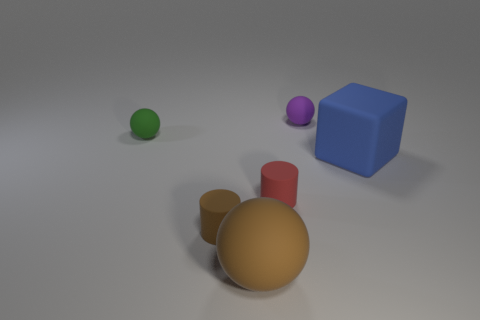How many big objects are either blue things or brown balls?
Offer a terse response. 2. The large thing to the right of the big brown matte object has what shape?
Keep it short and to the point. Cube. Are there any small balls of the same color as the big sphere?
Provide a succinct answer. No. There is a thing behind the green rubber ball; does it have the same size as the object right of the purple matte sphere?
Offer a terse response. No. Are there more red matte things behind the green matte sphere than tiny green things in front of the brown rubber sphere?
Your answer should be very brief. No. Are there any red cylinders made of the same material as the tiny purple object?
Your response must be concise. Yes. Is the color of the rubber block the same as the big sphere?
Offer a terse response. No. What is the tiny thing that is behind the brown matte cylinder and in front of the big blue object made of?
Your answer should be compact. Rubber. The block has what color?
Provide a succinct answer. Blue. How many other small matte objects are the same shape as the small green matte thing?
Offer a terse response. 1. 